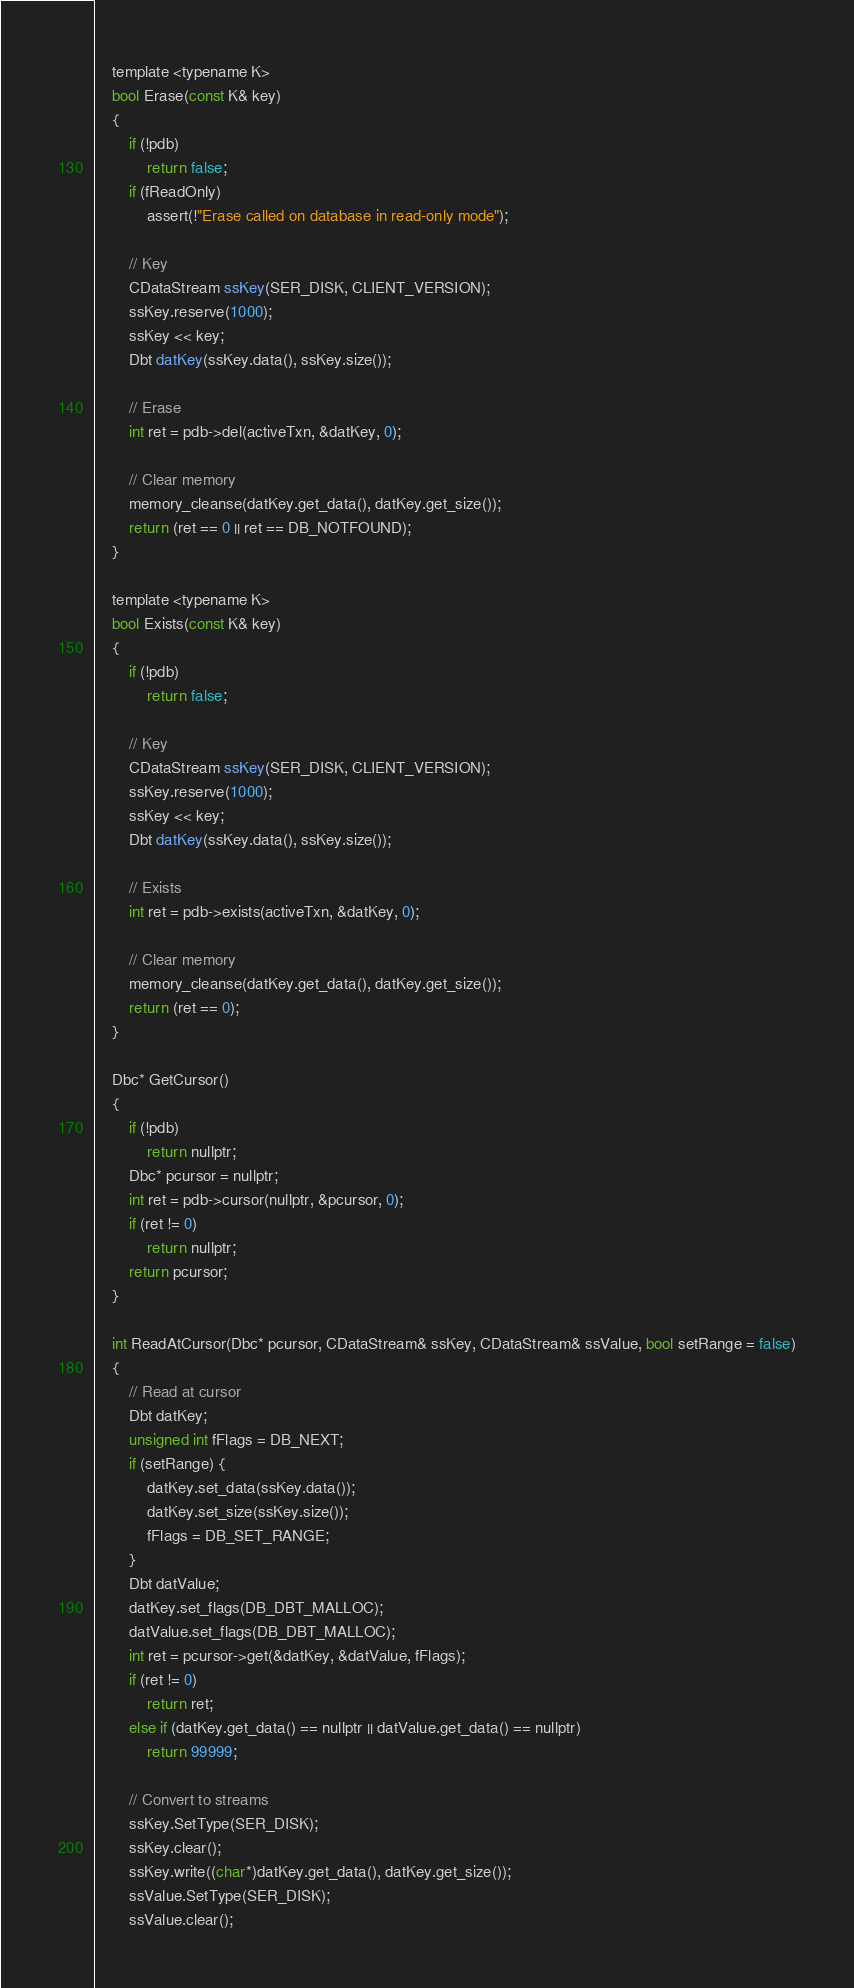Convert code to text. <code><loc_0><loc_0><loc_500><loc_500><_C_>
    template <typename K>
    bool Erase(const K& key)
    {
        if (!pdb)
            return false;
        if (fReadOnly)
            assert(!"Erase called on database in read-only mode");

        // Key
        CDataStream ssKey(SER_DISK, CLIENT_VERSION);
        ssKey.reserve(1000);
        ssKey << key;
        Dbt datKey(ssKey.data(), ssKey.size());

        // Erase
        int ret = pdb->del(activeTxn, &datKey, 0);

        // Clear memory
        memory_cleanse(datKey.get_data(), datKey.get_size());
        return (ret == 0 || ret == DB_NOTFOUND);
    }

    template <typename K>
    bool Exists(const K& key)
    {
        if (!pdb)
            return false;

        // Key
        CDataStream ssKey(SER_DISK, CLIENT_VERSION);
        ssKey.reserve(1000);
        ssKey << key;
        Dbt datKey(ssKey.data(), ssKey.size());

        // Exists
        int ret = pdb->exists(activeTxn, &datKey, 0);

        // Clear memory
        memory_cleanse(datKey.get_data(), datKey.get_size());
        return (ret == 0);
    }

    Dbc* GetCursor()
    {
        if (!pdb)
            return nullptr;
        Dbc* pcursor = nullptr;
        int ret = pdb->cursor(nullptr, &pcursor, 0);
        if (ret != 0)
            return nullptr;
        return pcursor;
    }

    int ReadAtCursor(Dbc* pcursor, CDataStream& ssKey, CDataStream& ssValue, bool setRange = false)
    {
        // Read at cursor
        Dbt datKey;
        unsigned int fFlags = DB_NEXT;
        if (setRange) {
            datKey.set_data(ssKey.data());
            datKey.set_size(ssKey.size());
            fFlags = DB_SET_RANGE;
        }
        Dbt datValue;
        datKey.set_flags(DB_DBT_MALLOC);
        datValue.set_flags(DB_DBT_MALLOC);
        int ret = pcursor->get(&datKey, &datValue, fFlags);
        if (ret != 0)
            return ret;
        else if (datKey.get_data() == nullptr || datValue.get_data() == nullptr)
            return 99999;

        // Convert to streams
        ssKey.SetType(SER_DISK);
        ssKey.clear();
        ssKey.write((char*)datKey.get_data(), datKey.get_size());
        ssValue.SetType(SER_DISK);
        ssValue.clear();</code> 